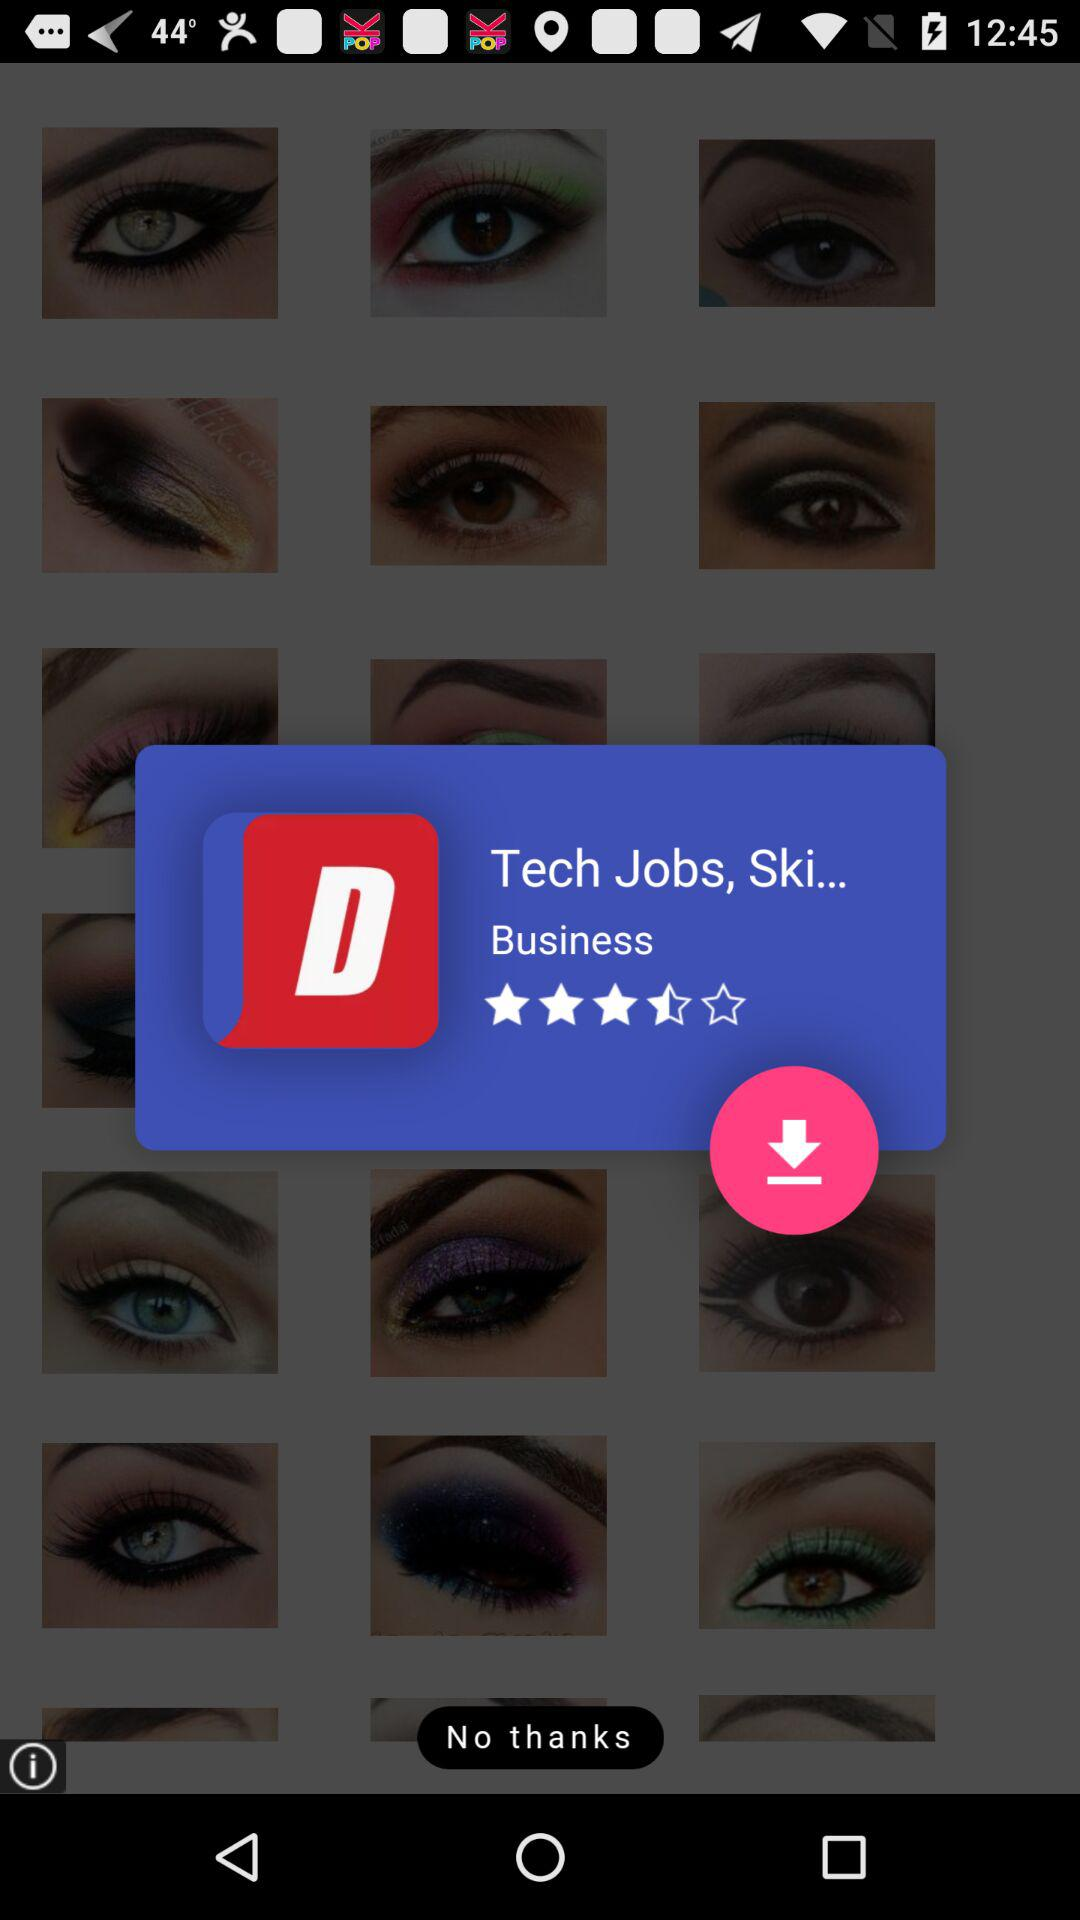What is the shown rating? The shown rating is 3.5 stars. 